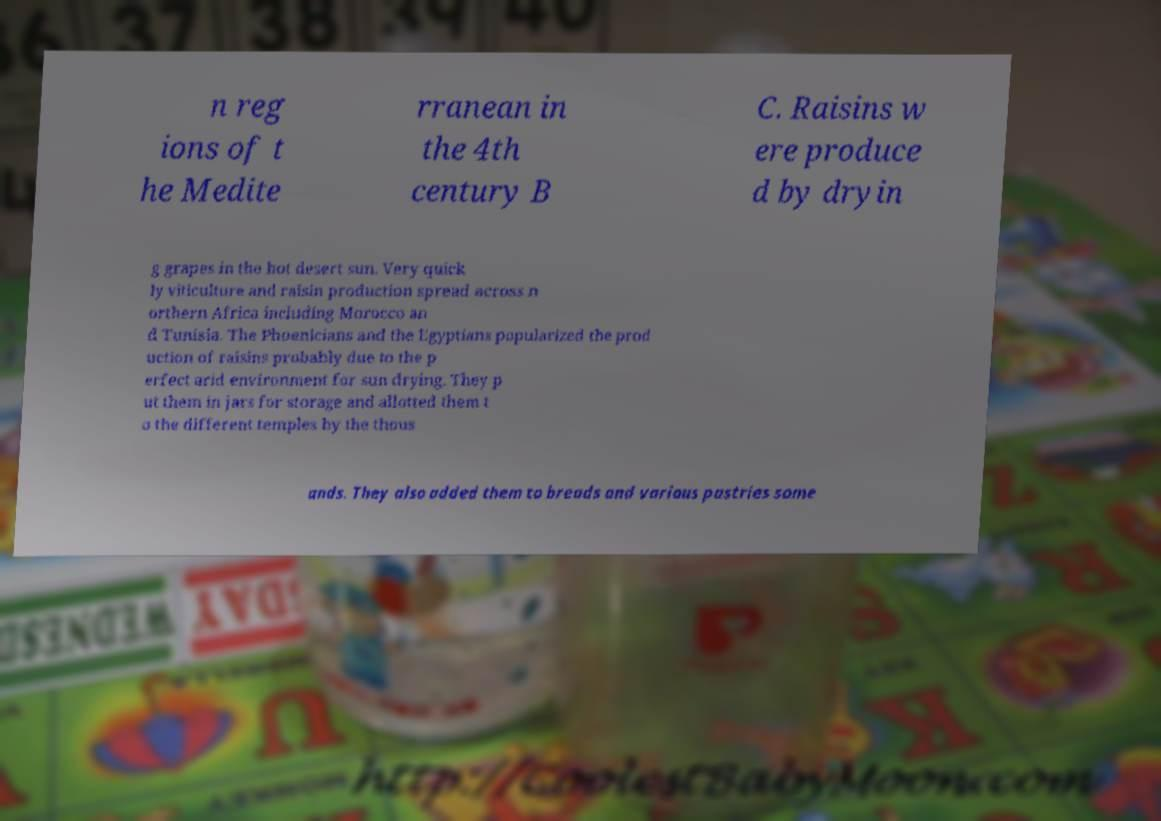What messages or text are displayed in this image? I need them in a readable, typed format. n reg ions of t he Medite rranean in the 4th century B C. Raisins w ere produce d by dryin g grapes in the hot desert sun. Very quick ly viticulture and raisin production spread across n orthern Africa including Morocco an d Tunisia. The Phoenicians and the Egyptians popularized the prod uction of raisins probably due to the p erfect arid environment for sun drying. They p ut them in jars for storage and allotted them t o the different temples by the thous ands. They also added them to breads and various pastries some 